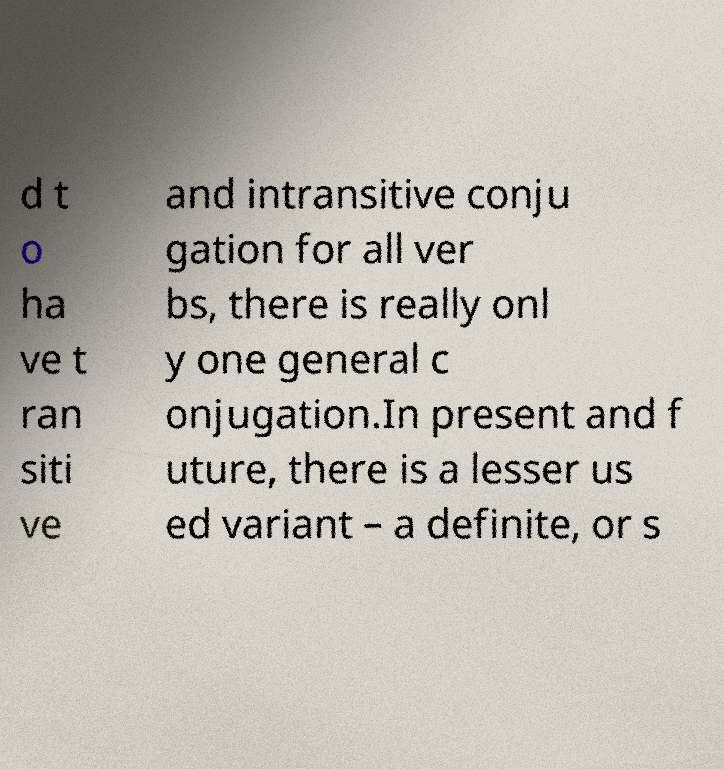Could you extract and type out the text from this image? d t o ha ve t ran siti ve and intransitive conju gation for all ver bs, there is really onl y one general c onjugation.In present and f uture, there is a lesser us ed variant – a definite, or s 